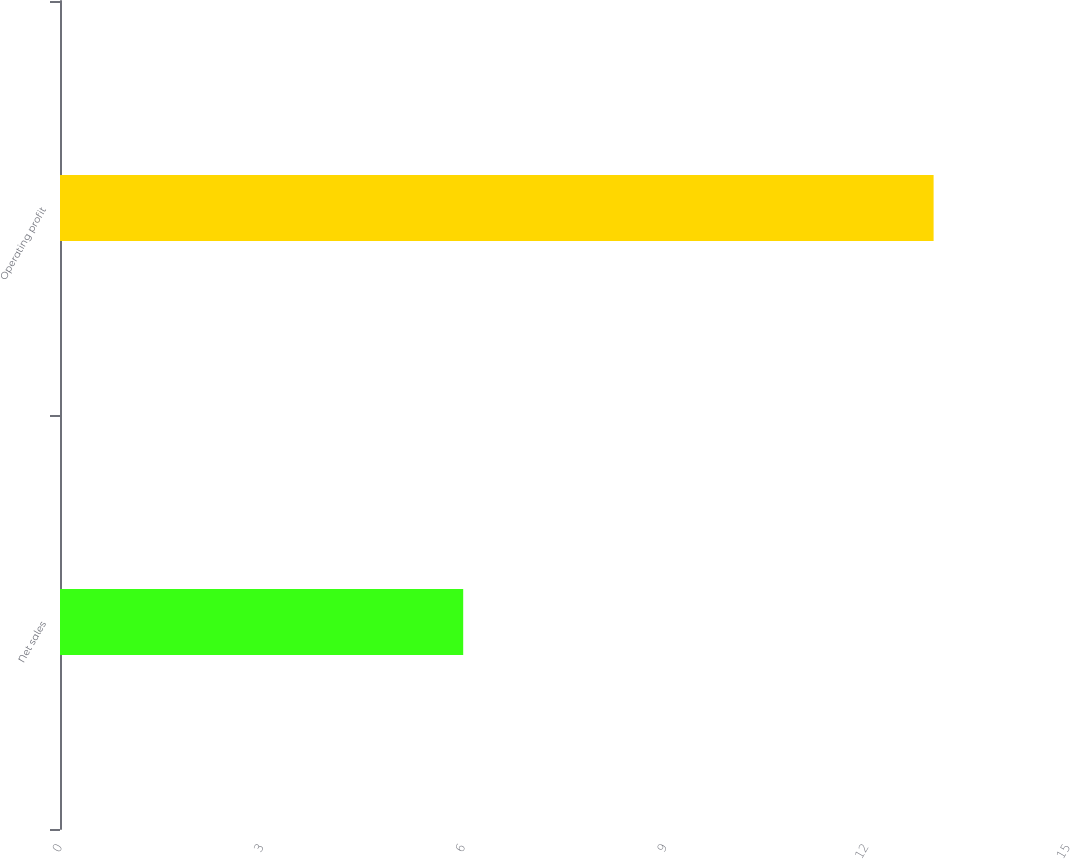<chart> <loc_0><loc_0><loc_500><loc_500><bar_chart><fcel>Net sales<fcel>Operating profit<nl><fcel>6<fcel>13<nl></chart> 